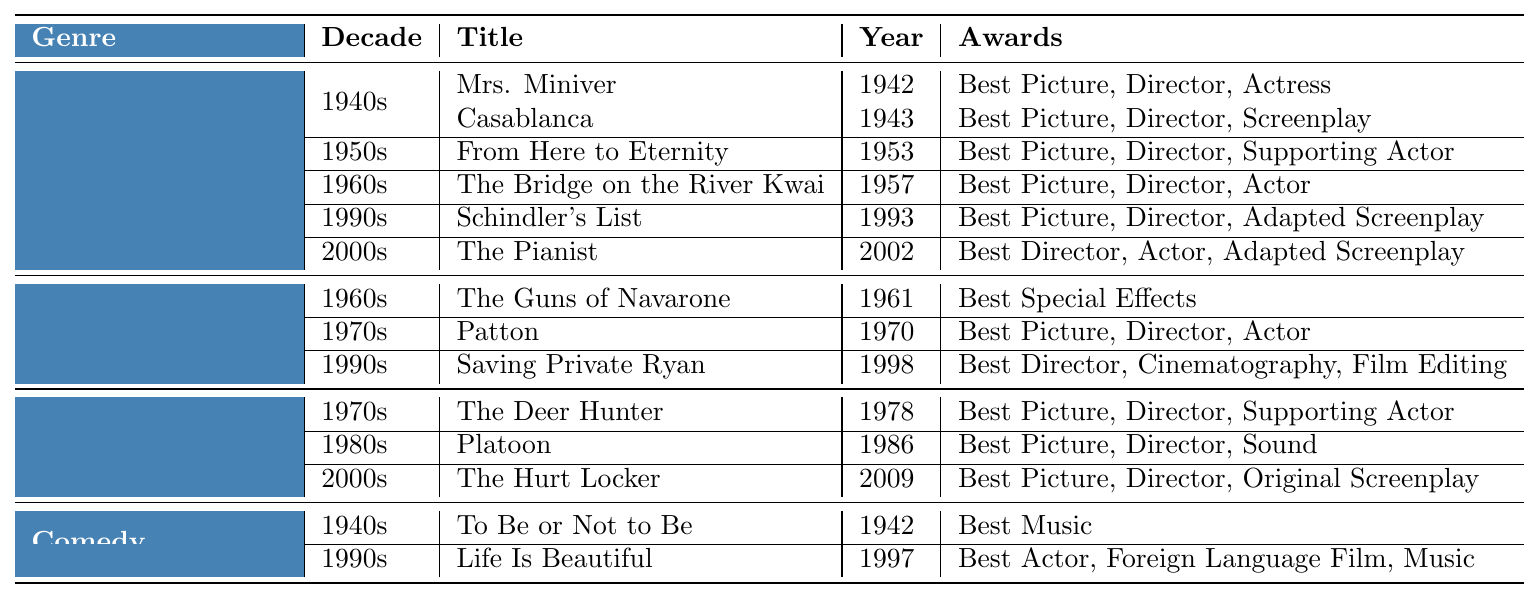What are the titles of dramatic WWII films from the 1940s? The table lists two dramatic films from the 1940s: "Mrs. Miniver" (1942) and "Casablanca" (1943).
Answer: "Mrs. Miniver" and "Casablanca" Which decade has the most Oscar-winning films listed in the table? The 1990s has four films listed in the table: "Schindler's List" (Drama), "Saving Private Ryan" (Action/Adventure), and "Life Is Beautiful" (Comedy).
Answer: 1990s Is "The Pianist" a drama film? Yes, "The Pianist" is listed under the Drama genre in the 2000s section of the table.
Answer: Yes How many awards did "Platoon" win? "Platoon" won three awards: Best Picture, Best Director, and Best Sound.
Answer: 3 Which director won awards for the films in the 1970s? The directors from the 1970s that won awards are Franklin J. Schaffner for "Patton," Michael Cimino for "The Deer Hunter," and there are no additional films from the War or Action/Adventure genre awarded for this decade.
Answer: 3 Which film won the Best Director award in the 2000s? "The Pianist" and "The Hurt Locker" both won the Best Director award in the 2000s section.
Answer: 2 Did any of the films in the Comedy category win more than one award? Yes, "Life Is Beautiful" won three awards while "To Be or Not to Be" won only one.
Answer: Yes What is the common theme among the top three awarded drama films from the 1990s? The common theme is that they all relate to significant historical events or figures during WWII, showcasing the struggles and moral complexities involved.
Answer: Historical significance How many unique genres are presented in the table? The table lists four unique genres: Drama, Action/Adventure, War, and Comedy.
Answer: 4 What award did "Saving Private Ryan" win for cinematography? "Saving Private Ryan" won the award for Best Cinematography.
Answer: Best Cinematography 